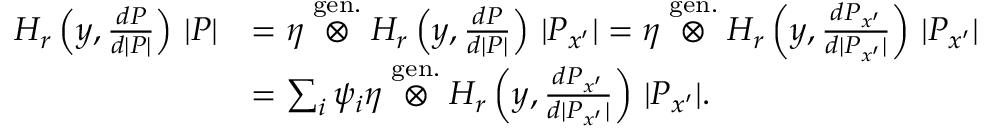Convert formula to latex. <formula><loc_0><loc_0><loc_500><loc_500>\begin{array} { r l } { H _ { r } \left ( y , \frac { d P } { d | P | } \right ) \, | P | } & { = \eta \stackrel { g e n . } { \otimes } H _ { r } \left ( y , \frac { d P } { d | P | } \right ) \, | P _ { x ^ { \prime } } | = \eta \stackrel { g e n . } { \otimes } H _ { r } \left ( y , \frac { d P _ { x ^ { \prime } } } { d | P _ { x ^ { \prime } } | } \right ) \, | P _ { x ^ { \prime } } | } \\ & { = \sum _ { i } \psi _ { i } \eta \stackrel { g e n . } { \otimes } H _ { r } \left ( y , \frac { d P _ { x ^ { \prime } } } { d | P _ { x ^ { \prime } } | } \right ) \, | P _ { x ^ { \prime } } | . } \end{array}</formula> 